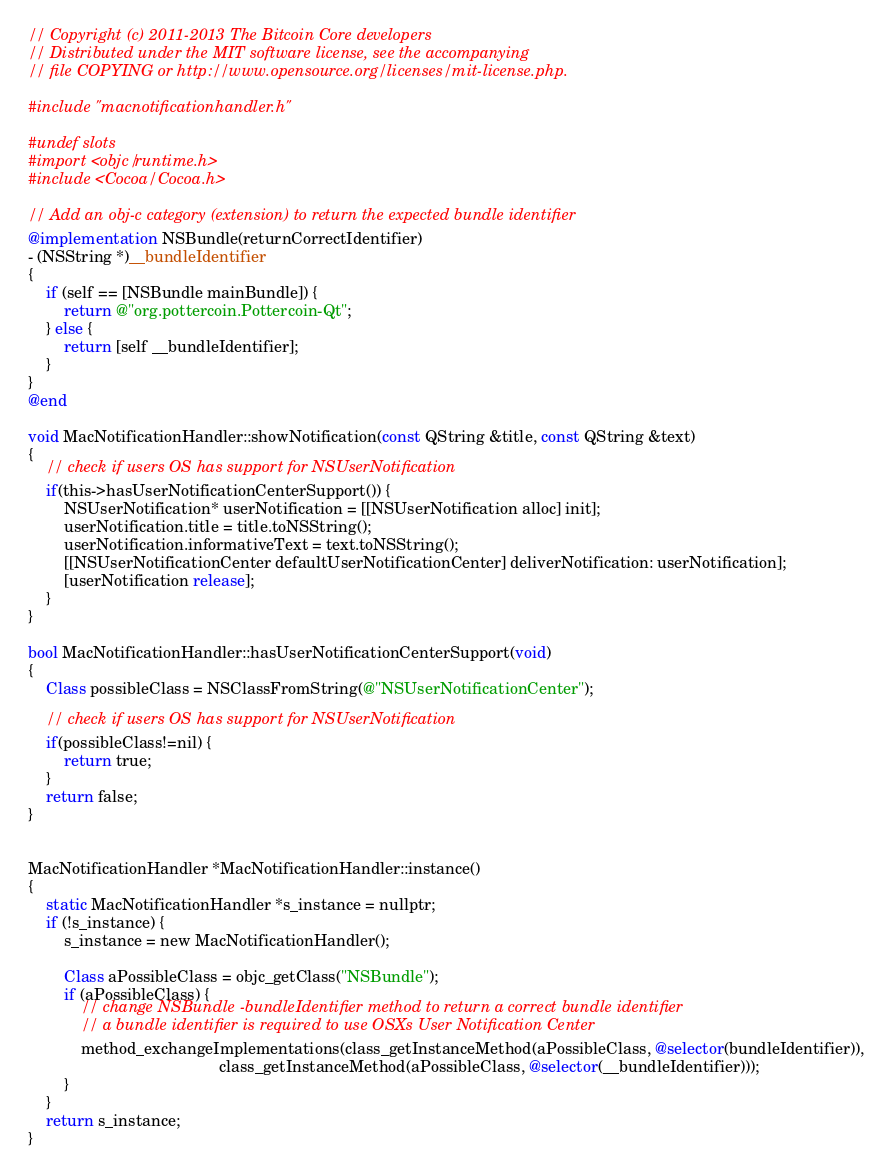Convert code to text. <code><loc_0><loc_0><loc_500><loc_500><_ObjectiveC_>// Copyright (c) 2011-2013 The Bitcoin Core developers
// Distributed under the MIT software license, see the accompanying
// file COPYING or http://www.opensource.org/licenses/mit-license.php.

#include "macnotificationhandler.h"

#undef slots
#import <objc/runtime.h>
#include <Cocoa/Cocoa.h>

// Add an obj-c category (extension) to return the expected bundle identifier
@implementation NSBundle(returnCorrectIdentifier)
- (NSString *)__bundleIdentifier
{
    if (self == [NSBundle mainBundle]) {
        return @"org.pottercoin.Pottercoin-Qt";
    } else {
        return [self __bundleIdentifier];
    }
}
@end

void MacNotificationHandler::showNotification(const QString &title, const QString &text)
{
    // check if users OS has support for NSUserNotification
    if(this->hasUserNotificationCenterSupport()) {
        NSUserNotification* userNotification = [[NSUserNotification alloc] init];
        userNotification.title = title.toNSString();
        userNotification.informativeText = text.toNSString();
        [[NSUserNotificationCenter defaultUserNotificationCenter] deliverNotification: userNotification];
        [userNotification release];
    }
}

bool MacNotificationHandler::hasUserNotificationCenterSupport(void)
{
    Class possibleClass = NSClassFromString(@"NSUserNotificationCenter");

    // check if users OS has support for NSUserNotification
    if(possibleClass!=nil) {
        return true;
    }
    return false;
}


MacNotificationHandler *MacNotificationHandler::instance()
{
    static MacNotificationHandler *s_instance = nullptr;
    if (!s_instance) {
        s_instance = new MacNotificationHandler();

        Class aPossibleClass = objc_getClass("NSBundle");
        if (aPossibleClass) {
            // change NSBundle -bundleIdentifier method to return a correct bundle identifier
            // a bundle identifier is required to use OSXs User Notification Center
            method_exchangeImplementations(class_getInstanceMethod(aPossibleClass, @selector(bundleIdentifier)),
                                           class_getInstanceMethod(aPossibleClass, @selector(__bundleIdentifier)));
        }
    }
    return s_instance;
}
</code> 